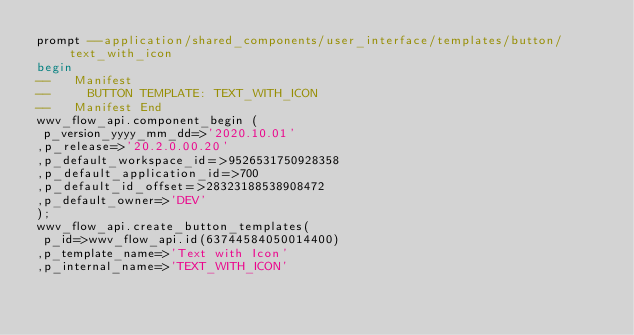Convert code to text. <code><loc_0><loc_0><loc_500><loc_500><_SQL_>prompt --application/shared_components/user_interface/templates/button/text_with_icon
begin
--   Manifest
--     BUTTON TEMPLATE: TEXT_WITH_ICON
--   Manifest End
wwv_flow_api.component_begin (
 p_version_yyyy_mm_dd=>'2020.10.01'
,p_release=>'20.2.0.00.20'
,p_default_workspace_id=>9526531750928358
,p_default_application_id=>700
,p_default_id_offset=>28323188538908472
,p_default_owner=>'DEV'
);
wwv_flow_api.create_button_templates(
 p_id=>wwv_flow_api.id(63744584050014400)
,p_template_name=>'Text with Icon'
,p_internal_name=>'TEXT_WITH_ICON'</code> 